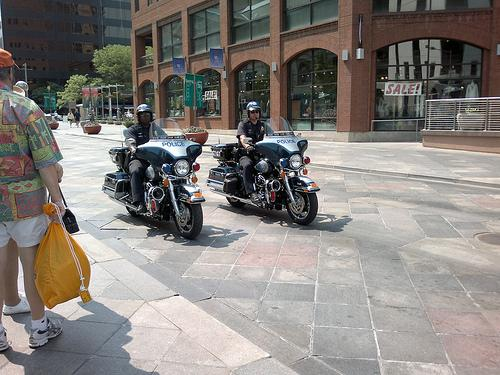Provide a brief description of the primary focus in the image. A man on a bicycle wearing a helmet and black uniform is accompanied by two police officers on motorcycles on a tiled street. Explain what the people in the image are doing and what objects are around them. A man on a cycle is riding on a tiled street with two police officers on motorcycles, as another man wearing an orange hat stands on the sidewalk, holding a yellow bag. In your own words, give a concise description of the main elements in the image. A cyclist wearing a helmet shares the tiled road with two motorbike-riding police officers, as onlookers observe from the sidewalk near a building with a sale sign. State the key components of the scene in the picture without elaborating. Man on a cycle, police officers on motorcycles, tiled street, yellow bag, sale sign in window, people on sidewalk. Describe the overall scene captured in the image. The image shows a man cycling on a street with two police officers riding motorcycles alongside him, while people stand on the sidewalk and a nearby building has a sale sign. Briefly describe the setting and main focus of the image. In an urban setting with a tiled street and buildings, the main focus lies on a cyclist accompanied by two police officers on motorcycles and a man holding a yellow bag. List five most interesting objects or details in the image. 5. Tiled street Mention the people in the picture and what they are wearing. There is a man on a bicycle wearing black uniform, helmet, and sunglasses, and another man with an orange hat and sneakers holding a yellow bag. Describe the interaction between the people and objects in the picture. A man wearing a helmet is cycling on a tiled street, while two police officers on motorcycles ride nearby, and a person holds a yellow bag on the sidewalk. Mention the most noticeable objects and their colors in the picture. Some prominent objects include an orange hat, a yellow bag, a blue helmet, white and blue shoes, and two green and white banners. 